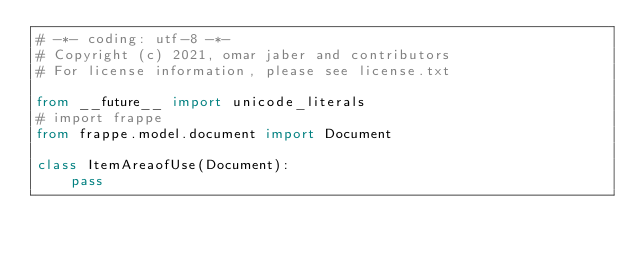Convert code to text. <code><loc_0><loc_0><loc_500><loc_500><_Python_># -*- coding: utf-8 -*-
# Copyright (c) 2021, omar jaber and contributors
# For license information, please see license.txt

from __future__ import unicode_literals
# import frappe
from frappe.model.document import Document

class ItemAreaofUse(Document):
	pass
</code> 